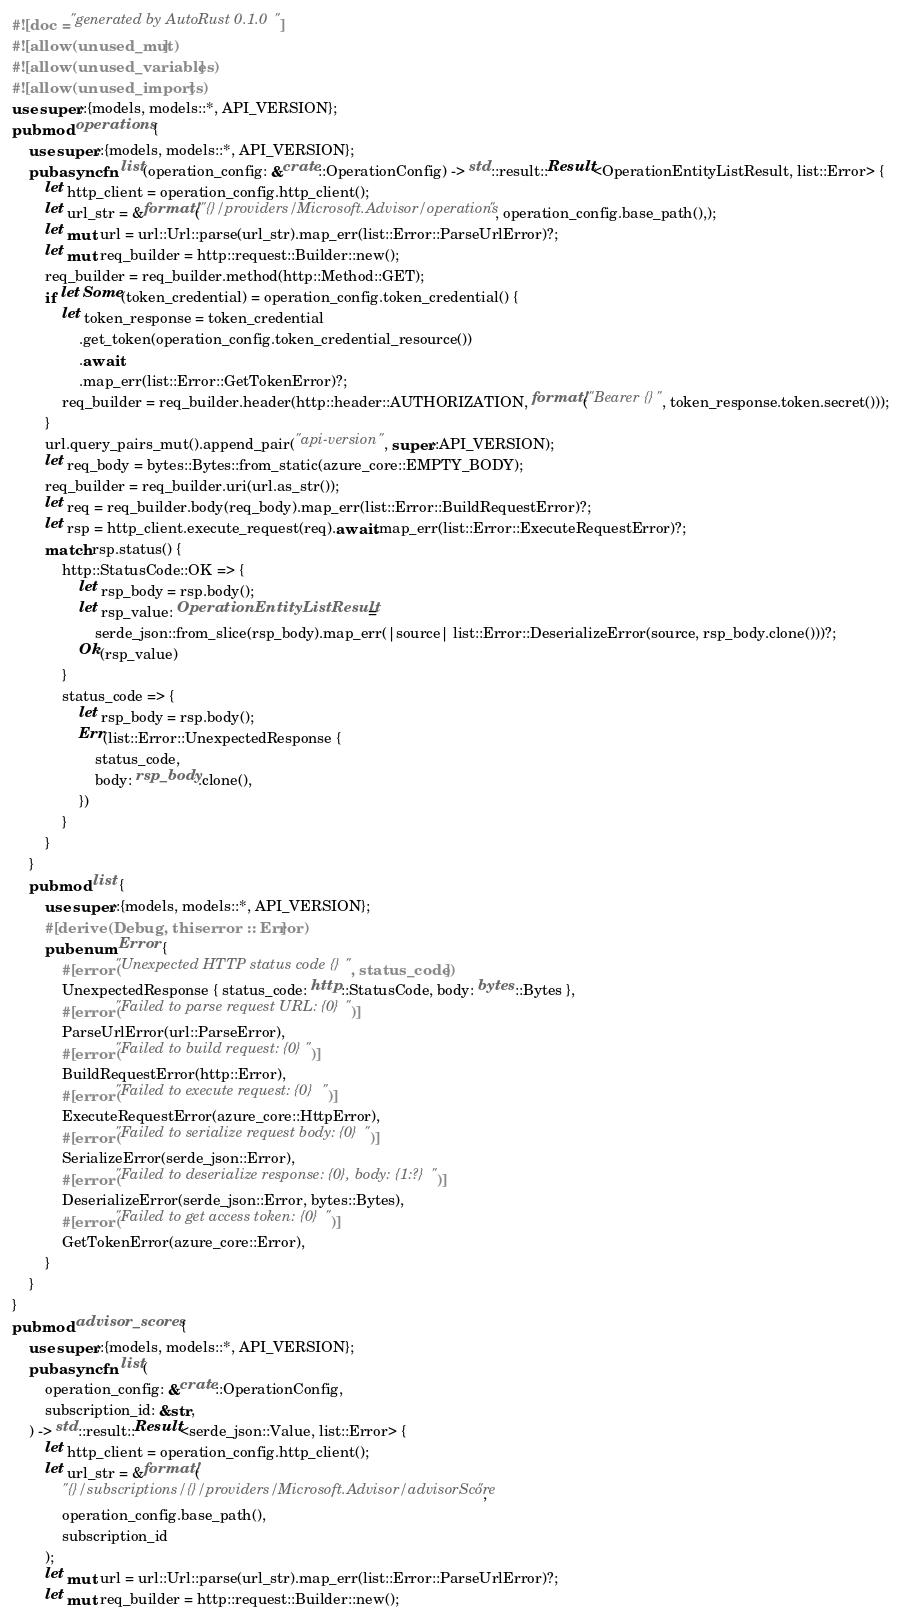Convert code to text. <code><loc_0><loc_0><loc_500><loc_500><_Rust_>#![doc = "generated by AutoRust 0.1.0"]
#![allow(unused_mut)]
#![allow(unused_variables)]
#![allow(unused_imports)]
use super::{models, models::*, API_VERSION};
pub mod operations {
    use super::{models, models::*, API_VERSION};
    pub async fn list(operation_config: &crate::OperationConfig) -> std::result::Result<OperationEntityListResult, list::Error> {
        let http_client = operation_config.http_client();
        let url_str = &format!("{}/providers/Microsoft.Advisor/operations", operation_config.base_path(),);
        let mut url = url::Url::parse(url_str).map_err(list::Error::ParseUrlError)?;
        let mut req_builder = http::request::Builder::new();
        req_builder = req_builder.method(http::Method::GET);
        if let Some(token_credential) = operation_config.token_credential() {
            let token_response = token_credential
                .get_token(operation_config.token_credential_resource())
                .await
                .map_err(list::Error::GetTokenError)?;
            req_builder = req_builder.header(http::header::AUTHORIZATION, format!("Bearer {}", token_response.token.secret()));
        }
        url.query_pairs_mut().append_pair("api-version", super::API_VERSION);
        let req_body = bytes::Bytes::from_static(azure_core::EMPTY_BODY);
        req_builder = req_builder.uri(url.as_str());
        let req = req_builder.body(req_body).map_err(list::Error::BuildRequestError)?;
        let rsp = http_client.execute_request(req).await.map_err(list::Error::ExecuteRequestError)?;
        match rsp.status() {
            http::StatusCode::OK => {
                let rsp_body = rsp.body();
                let rsp_value: OperationEntityListResult =
                    serde_json::from_slice(rsp_body).map_err(|source| list::Error::DeserializeError(source, rsp_body.clone()))?;
                Ok(rsp_value)
            }
            status_code => {
                let rsp_body = rsp.body();
                Err(list::Error::UnexpectedResponse {
                    status_code,
                    body: rsp_body.clone(),
                })
            }
        }
    }
    pub mod list {
        use super::{models, models::*, API_VERSION};
        #[derive(Debug, thiserror :: Error)]
        pub enum Error {
            #[error("Unexpected HTTP status code {}", status_code)]
            UnexpectedResponse { status_code: http::StatusCode, body: bytes::Bytes },
            #[error("Failed to parse request URL: {0}")]
            ParseUrlError(url::ParseError),
            #[error("Failed to build request: {0}")]
            BuildRequestError(http::Error),
            #[error("Failed to execute request: {0}")]
            ExecuteRequestError(azure_core::HttpError),
            #[error("Failed to serialize request body: {0}")]
            SerializeError(serde_json::Error),
            #[error("Failed to deserialize response: {0}, body: {1:?}")]
            DeserializeError(serde_json::Error, bytes::Bytes),
            #[error("Failed to get access token: {0}")]
            GetTokenError(azure_core::Error),
        }
    }
}
pub mod advisor_scores {
    use super::{models, models::*, API_VERSION};
    pub async fn list(
        operation_config: &crate::OperationConfig,
        subscription_id: &str,
    ) -> std::result::Result<serde_json::Value, list::Error> {
        let http_client = operation_config.http_client();
        let url_str = &format!(
            "{}/subscriptions/{}/providers/Microsoft.Advisor/advisorScore",
            operation_config.base_path(),
            subscription_id
        );
        let mut url = url::Url::parse(url_str).map_err(list::Error::ParseUrlError)?;
        let mut req_builder = http::request::Builder::new();</code> 